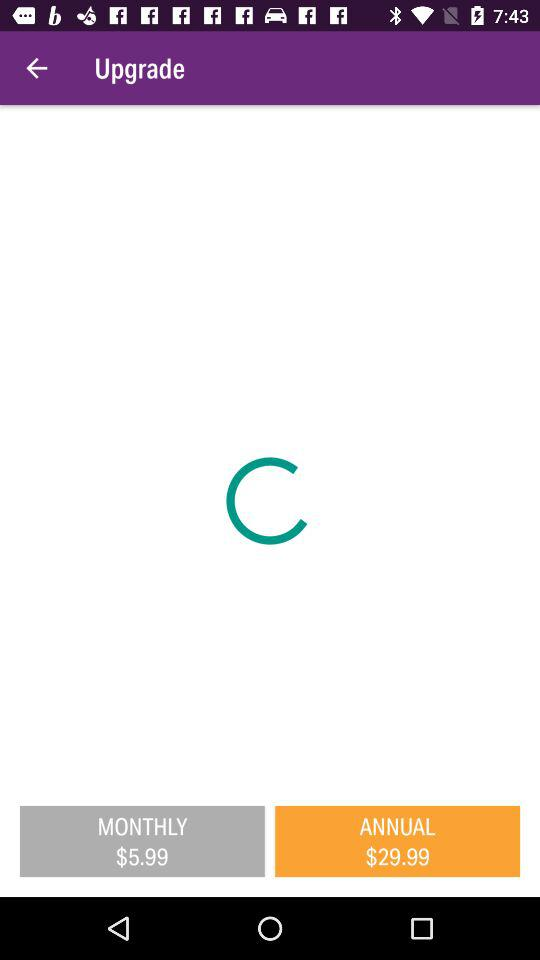How much more does the annual subscription cost than the monthly subscription?
Answer the question using a single word or phrase. $24.00 